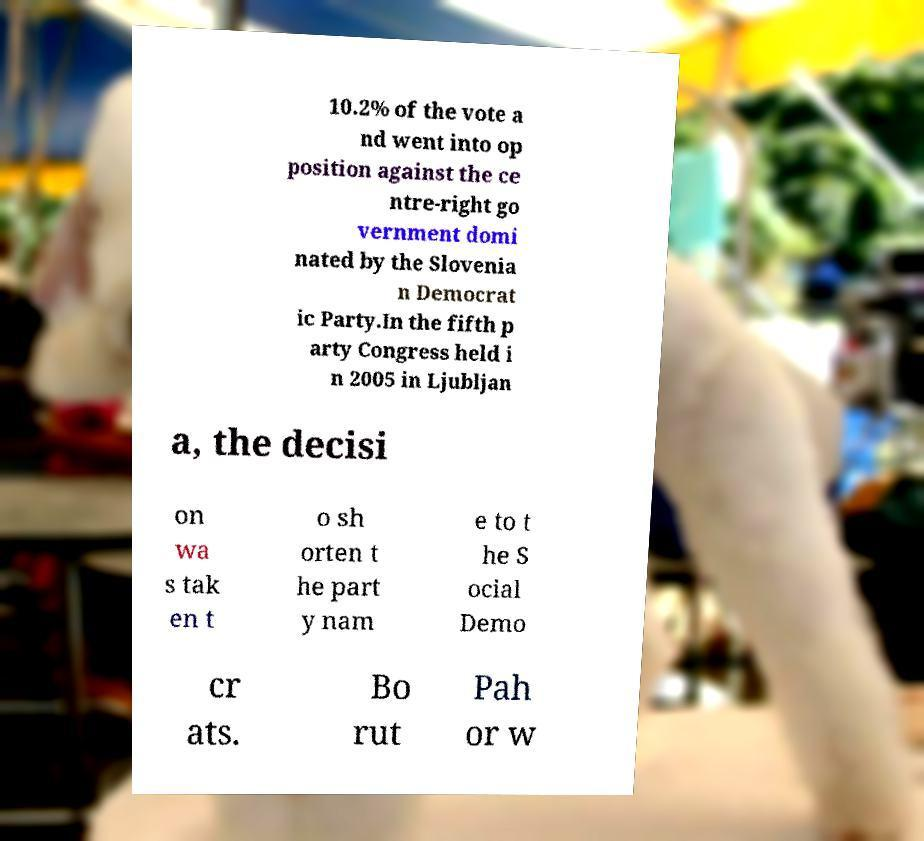There's text embedded in this image that I need extracted. Can you transcribe it verbatim? 10.2% of the vote a nd went into op position against the ce ntre-right go vernment domi nated by the Slovenia n Democrat ic Party.In the fifth p arty Congress held i n 2005 in Ljubljan a, the decisi on wa s tak en t o sh orten t he part y nam e to t he S ocial Demo cr ats. Bo rut Pah or w 